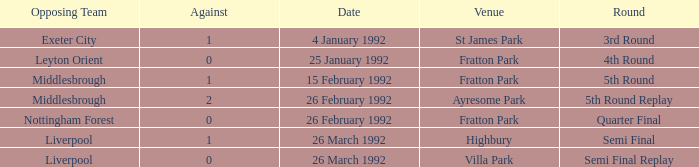What was the stage for villa park? Semi Final Replay. 